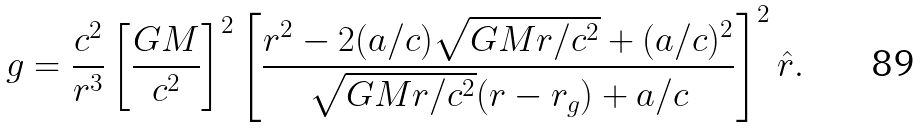Convert formula to latex. <formula><loc_0><loc_0><loc_500><loc_500>g = \frac { c ^ { 2 } } { r ^ { 3 } } \left [ \frac { G M } { c ^ { 2 } } \right ] ^ { 2 } \left [ \frac { r ^ { 2 } - 2 ( a / c ) \sqrt { G M r / c ^ { 2 } } + ( a / c ) ^ { 2 } } { \sqrt { G M r / c ^ { 2 } } ( r - r _ { g } ) + a / c } \right ] ^ { 2 } \hat { r } .</formula> 